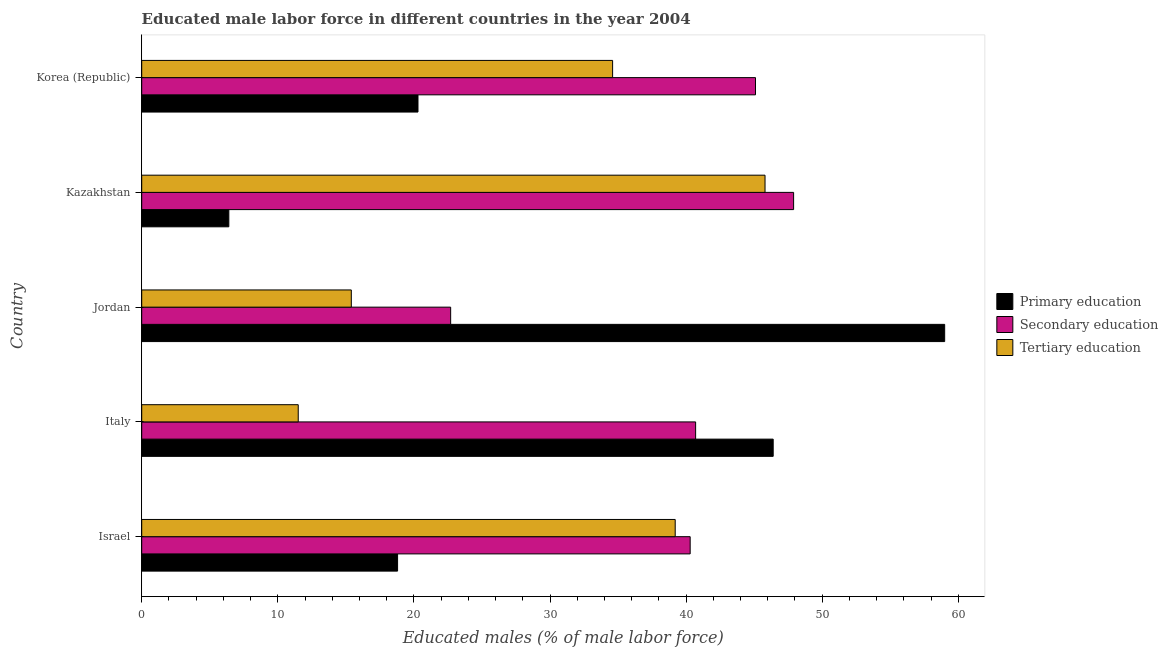How many different coloured bars are there?
Give a very brief answer. 3. Are the number of bars on each tick of the Y-axis equal?
Provide a succinct answer. Yes. How many bars are there on the 1st tick from the bottom?
Give a very brief answer. 3. What is the percentage of male labor force who received tertiary education in Israel?
Your response must be concise. 39.2. Across all countries, what is the maximum percentage of male labor force who received tertiary education?
Your response must be concise. 45.8. Across all countries, what is the minimum percentage of male labor force who received primary education?
Make the answer very short. 6.4. In which country was the percentage of male labor force who received primary education maximum?
Make the answer very short. Jordan. In which country was the percentage of male labor force who received tertiary education minimum?
Give a very brief answer. Italy. What is the total percentage of male labor force who received secondary education in the graph?
Your answer should be very brief. 196.7. What is the difference between the percentage of male labor force who received primary education in Italy and that in Jordan?
Provide a short and direct response. -12.6. What is the difference between the percentage of male labor force who received secondary education in Israel and the percentage of male labor force who received primary education in Jordan?
Provide a succinct answer. -18.7. What is the average percentage of male labor force who received tertiary education per country?
Your answer should be very brief. 29.3. In how many countries, is the percentage of male labor force who received primary education greater than 30 %?
Your answer should be very brief. 2. What is the ratio of the percentage of male labor force who received secondary education in Italy to that in Korea (Republic)?
Offer a very short reply. 0.9. What is the difference between the highest and the second highest percentage of male labor force who received primary education?
Your answer should be compact. 12.6. What is the difference between the highest and the lowest percentage of male labor force who received primary education?
Keep it short and to the point. 52.6. Is the sum of the percentage of male labor force who received secondary education in Israel and Korea (Republic) greater than the maximum percentage of male labor force who received primary education across all countries?
Your answer should be compact. Yes. What does the 2nd bar from the top in Kazakhstan represents?
Provide a succinct answer. Secondary education. Is it the case that in every country, the sum of the percentage of male labor force who received primary education and percentage of male labor force who received secondary education is greater than the percentage of male labor force who received tertiary education?
Offer a terse response. Yes. How many bars are there?
Provide a short and direct response. 15. Are all the bars in the graph horizontal?
Your answer should be very brief. Yes. What is the difference between two consecutive major ticks on the X-axis?
Ensure brevity in your answer.  10. Are the values on the major ticks of X-axis written in scientific E-notation?
Give a very brief answer. No. Does the graph contain any zero values?
Provide a short and direct response. No. How are the legend labels stacked?
Offer a very short reply. Vertical. What is the title of the graph?
Your answer should be compact. Educated male labor force in different countries in the year 2004. Does "Resident buildings and public services" appear as one of the legend labels in the graph?
Ensure brevity in your answer.  No. What is the label or title of the X-axis?
Keep it short and to the point. Educated males (% of male labor force). What is the label or title of the Y-axis?
Your response must be concise. Country. What is the Educated males (% of male labor force) of Primary education in Israel?
Offer a terse response. 18.8. What is the Educated males (% of male labor force) in Secondary education in Israel?
Provide a succinct answer. 40.3. What is the Educated males (% of male labor force) of Tertiary education in Israel?
Your answer should be compact. 39.2. What is the Educated males (% of male labor force) of Primary education in Italy?
Give a very brief answer. 46.4. What is the Educated males (% of male labor force) in Secondary education in Italy?
Ensure brevity in your answer.  40.7. What is the Educated males (% of male labor force) in Primary education in Jordan?
Provide a short and direct response. 59. What is the Educated males (% of male labor force) in Secondary education in Jordan?
Offer a terse response. 22.7. What is the Educated males (% of male labor force) of Tertiary education in Jordan?
Ensure brevity in your answer.  15.4. What is the Educated males (% of male labor force) in Primary education in Kazakhstan?
Provide a short and direct response. 6.4. What is the Educated males (% of male labor force) in Secondary education in Kazakhstan?
Make the answer very short. 47.9. What is the Educated males (% of male labor force) in Tertiary education in Kazakhstan?
Offer a very short reply. 45.8. What is the Educated males (% of male labor force) of Primary education in Korea (Republic)?
Your response must be concise. 20.3. What is the Educated males (% of male labor force) of Secondary education in Korea (Republic)?
Your answer should be very brief. 45.1. What is the Educated males (% of male labor force) in Tertiary education in Korea (Republic)?
Make the answer very short. 34.6. Across all countries, what is the maximum Educated males (% of male labor force) of Primary education?
Ensure brevity in your answer.  59. Across all countries, what is the maximum Educated males (% of male labor force) of Secondary education?
Provide a succinct answer. 47.9. Across all countries, what is the maximum Educated males (% of male labor force) of Tertiary education?
Provide a succinct answer. 45.8. Across all countries, what is the minimum Educated males (% of male labor force) of Primary education?
Provide a short and direct response. 6.4. Across all countries, what is the minimum Educated males (% of male labor force) of Secondary education?
Make the answer very short. 22.7. What is the total Educated males (% of male labor force) in Primary education in the graph?
Ensure brevity in your answer.  150.9. What is the total Educated males (% of male labor force) of Secondary education in the graph?
Provide a short and direct response. 196.7. What is the total Educated males (% of male labor force) in Tertiary education in the graph?
Offer a terse response. 146.5. What is the difference between the Educated males (% of male labor force) of Primary education in Israel and that in Italy?
Your answer should be very brief. -27.6. What is the difference between the Educated males (% of male labor force) in Secondary education in Israel and that in Italy?
Give a very brief answer. -0.4. What is the difference between the Educated males (% of male labor force) in Tertiary education in Israel and that in Italy?
Ensure brevity in your answer.  27.7. What is the difference between the Educated males (% of male labor force) of Primary education in Israel and that in Jordan?
Ensure brevity in your answer.  -40.2. What is the difference between the Educated males (% of male labor force) in Secondary education in Israel and that in Jordan?
Make the answer very short. 17.6. What is the difference between the Educated males (% of male labor force) of Tertiary education in Israel and that in Jordan?
Ensure brevity in your answer.  23.8. What is the difference between the Educated males (% of male labor force) of Tertiary education in Israel and that in Kazakhstan?
Your response must be concise. -6.6. What is the difference between the Educated males (% of male labor force) of Primary education in Israel and that in Korea (Republic)?
Offer a terse response. -1.5. What is the difference between the Educated males (% of male labor force) of Tertiary education in Israel and that in Korea (Republic)?
Offer a very short reply. 4.6. What is the difference between the Educated males (% of male labor force) in Secondary education in Italy and that in Jordan?
Make the answer very short. 18. What is the difference between the Educated males (% of male labor force) of Secondary education in Italy and that in Kazakhstan?
Provide a short and direct response. -7.2. What is the difference between the Educated males (% of male labor force) of Tertiary education in Italy and that in Kazakhstan?
Offer a very short reply. -34.3. What is the difference between the Educated males (% of male labor force) in Primary education in Italy and that in Korea (Republic)?
Your answer should be very brief. 26.1. What is the difference between the Educated males (% of male labor force) of Secondary education in Italy and that in Korea (Republic)?
Your answer should be compact. -4.4. What is the difference between the Educated males (% of male labor force) of Tertiary education in Italy and that in Korea (Republic)?
Give a very brief answer. -23.1. What is the difference between the Educated males (% of male labor force) of Primary education in Jordan and that in Kazakhstan?
Make the answer very short. 52.6. What is the difference between the Educated males (% of male labor force) of Secondary education in Jordan and that in Kazakhstan?
Make the answer very short. -25.2. What is the difference between the Educated males (% of male labor force) of Tertiary education in Jordan and that in Kazakhstan?
Your answer should be very brief. -30.4. What is the difference between the Educated males (% of male labor force) of Primary education in Jordan and that in Korea (Republic)?
Give a very brief answer. 38.7. What is the difference between the Educated males (% of male labor force) in Secondary education in Jordan and that in Korea (Republic)?
Make the answer very short. -22.4. What is the difference between the Educated males (% of male labor force) of Tertiary education in Jordan and that in Korea (Republic)?
Provide a succinct answer. -19.2. What is the difference between the Educated males (% of male labor force) in Primary education in Kazakhstan and that in Korea (Republic)?
Offer a terse response. -13.9. What is the difference between the Educated males (% of male labor force) in Tertiary education in Kazakhstan and that in Korea (Republic)?
Your response must be concise. 11.2. What is the difference between the Educated males (% of male labor force) in Primary education in Israel and the Educated males (% of male labor force) in Secondary education in Italy?
Provide a short and direct response. -21.9. What is the difference between the Educated males (% of male labor force) in Primary education in Israel and the Educated males (% of male labor force) in Tertiary education in Italy?
Provide a short and direct response. 7.3. What is the difference between the Educated males (% of male labor force) of Secondary education in Israel and the Educated males (% of male labor force) of Tertiary education in Italy?
Give a very brief answer. 28.8. What is the difference between the Educated males (% of male labor force) of Secondary education in Israel and the Educated males (% of male labor force) of Tertiary education in Jordan?
Provide a short and direct response. 24.9. What is the difference between the Educated males (% of male labor force) in Primary education in Israel and the Educated males (% of male labor force) in Secondary education in Kazakhstan?
Provide a succinct answer. -29.1. What is the difference between the Educated males (% of male labor force) of Primary education in Israel and the Educated males (% of male labor force) of Tertiary education in Kazakhstan?
Provide a succinct answer. -27. What is the difference between the Educated males (% of male labor force) in Primary education in Israel and the Educated males (% of male labor force) in Secondary education in Korea (Republic)?
Make the answer very short. -26.3. What is the difference between the Educated males (% of male labor force) of Primary education in Israel and the Educated males (% of male labor force) of Tertiary education in Korea (Republic)?
Offer a terse response. -15.8. What is the difference between the Educated males (% of male labor force) of Primary education in Italy and the Educated males (% of male labor force) of Secondary education in Jordan?
Make the answer very short. 23.7. What is the difference between the Educated males (% of male labor force) of Primary education in Italy and the Educated males (% of male labor force) of Tertiary education in Jordan?
Make the answer very short. 31. What is the difference between the Educated males (% of male labor force) in Secondary education in Italy and the Educated males (% of male labor force) in Tertiary education in Jordan?
Offer a terse response. 25.3. What is the difference between the Educated males (% of male labor force) in Primary education in Italy and the Educated males (% of male labor force) in Tertiary education in Kazakhstan?
Provide a succinct answer. 0.6. What is the difference between the Educated males (% of male labor force) of Secondary education in Italy and the Educated males (% of male labor force) of Tertiary education in Kazakhstan?
Offer a terse response. -5.1. What is the difference between the Educated males (% of male labor force) in Primary education in Italy and the Educated males (% of male labor force) in Secondary education in Korea (Republic)?
Your response must be concise. 1.3. What is the difference between the Educated males (% of male labor force) in Primary education in Italy and the Educated males (% of male labor force) in Tertiary education in Korea (Republic)?
Provide a succinct answer. 11.8. What is the difference between the Educated males (% of male labor force) in Primary education in Jordan and the Educated males (% of male labor force) in Secondary education in Kazakhstan?
Provide a short and direct response. 11.1. What is the difference between the Educated males (% of male labor force) of Secondary education in Jordan and the Educated males (% of male labor force) of Tertiary education in Kazakhstan?
Make the answer very short. -23.1. What is the difference between the Educated males (% of male labor force) in Primary education in Jordan and the Educated males (% of male labor force) in Secondary education in Korea (Republic)?
Your response must be concise. 13.9. What is the difference between the Educated males (% of male labor force) in Primary education in Jordan and the Educated males (% of male labor force) in Tertiary education in Korea (Republic)?
Ensure brevity in your answer.  24.4. What is the difference between the Educated males (% of male labor force) of Secondary education in Jordan and the Educated males (% of male labor force) of Tertiary education in Korea (Republic)?
Make the answer very short. -11.9. What is the difference between the Educated males (% of male labor force) in Primary education in Kazakhstan and the Educated males (% of male labor force) in Secondary education in Korea (Republic)?
Offer a terse response. -38.7. What is the difference between the Educated males (% of male labor force) of Primary education in Kazakhstan and the Educated males (% of male labor force) of Tertiary education in Korea (Republic)?
Offer a terse response. -28.2. What is the difference between the Educated males (% of male labor force) of Secondary education in Kazakhstan and the Educated males (% of male labor force) of Tertiary education in Korea (Republic)?
Provide a succinct answer. 13.3. What is the average Educated males (% of male labor force) of Primary education per country?
Your answer should be very brief. 30.18. What is the average Educated males (% of male labor force) in Secondary education per country?
Your answer should be very brief. 39.34. What is the average Educated males (% of male labor force) of Tertiary education per country?
Give a very brief answer. 29.3. What is the difference between the Educated males (% of male labor force) in Primary education and Educated males (% of male labor force) in Secondary education in Israel?
Offer a very short reply. -21.5. What is the difference between the Educated males (% of male labor force) of Primary education and Educated males (% of male labor force) of Tertiary education in Israel?
Provide a short and direct response. -20.4. What is the difference between the Educated males (% of male labor force) of Secondary education and Educated males (% of male labor force) of Tertiary education in Israel?
Provide a short and direct response. 1.1. What is the difference between the Educated males (% of male labor force) in Primary education and Educated males (% of male labor force) in Secondary education in Italy?
Make the answer very short. 5.7. What is the difference between the Educated males (% of male labor force) in Primary education and Educated males (% of male labor force) in Tertiary education in Italy?
Your response must be concise. 34.9. What is the difference between the Educated males (% of male labor force) of Secondary education and Educated males (% of male labor force) of Tertiary education in Italy?
Your answer should be compact. 29.2. What is the difference between the Educated males (% of male labor force) of Primary education and Educated males (% of male labor force) of Secondary education in Jordan?
Provide a succinct answer. 36.3. What is the difference between the Educated males (% of male labor force) in Primary education and Educated males (% of male labor force) in Tertiary education in Jordan?
Make the answer very short. 43.6. What is the difference between the Educated males (% of male labor force) of Primary education and Educated males (% of male labor force) of Secondary education in Kazakhstan?
Ensure brevity in your answer.  -41.5. What is the difference between the Educated males (% of male labor force) in Primary education and Educated males (% of male labor force) in Tertiary education in Kazakhstan?
Provide a short and direct response. -39.4. What is the difference between the Educated males (% of male labor force) in Primary education and Educated males (% of male labor force) in Secondary education in Korea (Republic)?
Your answer should be very brief. -24.8. What is the difference between the Educated males (% of male labor force) in Primary education and Educated males (% of male labor force) in Tertiary education in Korea (Republic)?
Your response must be concise. -14.3. What is the ratio of the Educated males (% of male labor force) of Primary education in Israel to that in Italy?
Make the answer very short. 0.41. What is the ratio of the Educated males (% of male labor force) of Secondary education in Israel to that in Italy?
Make the answer very short. 0.99. What is the ratio of the Educated males (% of male labor force) of Tertiary education in Israel to that in Italy?
Offer a very short reply. 3.41. What is the ratio of the Educated males (% of male labor force) of Primary education in Israel to that in Jordan?
Offer a terse response. 0.32. What is the ratio of the Educated males (% of male labor force) in Secondary education in Israel to that in Jordan?
Keep it short and to the point. 1.78. What is the ratio of the Educated males (% of male labor force) in Tertiary education in Israel to that in Jordan?
Your answer should be very brief. 2.55. What is the ratio of the Educated males (% of male labor force) in Primary education in Israel to that in Kazakhstan?
Provide a succinct answer. 2.94. What is the ratio of the Educated males (% of male labor force) in Secondary education in Israel to that in Kazakhstan?
Give a very brief answer. 0.84. What is the ratio of the Educated males (% of male labor force) in Tertiary education in Israel to that in Kazakhstan?
Give a very brief answer. 0.86. What is the ratio of the Educated males (% of male labor force) of Primary education in Israel to that in Korea (Republic)?
Provide a short and direct response. 0.93. What is the ratio of the Educated males (% of male labor force) in Secondary education in Israel to that in Korea (Republic)?
Offer a terse response. 0.89. What is the ratio of the Educated males (% of male labor force) of Tertiary education in Israel to that in Korea (Republic)?
Ensure brevity in your answer.  1.13. What is the ratio of the Educated males (% of male labor force) in Primary education in Italy to that in Jordan?
Your response must be concise. 0.79. What is the ratio of the Educated males (% of male labor force) of Secondary education in Italy to that in Jordan?
Offer a terse response. 1.79. What is the ratio of the Educated males (% of male labor force) in Tertiary education in Italy to that in Jordan?
Your answer should be very brief. 0.75. What is the ratio of the Educated males (% of male labor force) in Primary education in Italy to that in Kazakhstan?
Give a very brief answer. 7.25. What is the ratio of the Educated males (% of male labor force) in Secondary education in Italy to that in Kazakhstan?
Your answer should be compact. 0.85. What is the ratio of the Educated males (% of male labor force) in Tertiary education in Italy to that in Kazakhstan?
Provide a succinct answer. 0.25. What is the ratio of the Educated males (% of male labor force) of Primary education in Italy to that in Korea (Republic)?
Offer a terse response. 2.29. What is the ratio of the Educated males (% of male labor force) of Secondary education in Italy to that in Korea (Republic)?
Give a very brief answer. 0.9. What is the ratio of the Educated males (% of male labor force) of Tertiary education in Italy to that in Korea (Republic)?
Provide a short and direct response. 0.33. What is the ratio of the Educated males (% of male labor force) of Primary education in Jordan to that in Kazakhstan?
Provide a succinct answer. 9.22. What is the ratio of the Educated males (% of male labor force) of Secondary education in Jordan to that in Kazakhstan?
Make the answer very short. 0.47. What is the ratio of the Educated males (% of male labor force) of Tertiary education in Jordan to that in Kazakhstan?
Ensure brevity in your answer.  0.34. What is the ratio of the Educated males (% of male labor force) of Primary education in Jordan to that in Korea (Republic)?
Ensure brevity in your answer.  2.91. What is the ratio of the Educated males (% of male labor force) of Secondary education in Jordan to that in Korea (Republic)?
Make the answer very short. 0.5. What is the ratio of the Educated males (% of male labor force) of Tertiary education in Jordan to that in Korea (Republic)?
Your answer should be very brief. 0.45. What is the ratio of the Educated males (% of male labor force) of Primary education in Kazakhstan to that in Korea (Republic)?
Your answer should be very brief. 0.32. What is the ratio of the Educated males (% of male labor force) in Secondary education in Kazakhstan to that in Korea (Republic)?
Ensure brevity in your answer.  1.06. What is the ratio of the Educated males (% of male labor force) of Tertiary education in Kazakhstan to that in Korea (Republic)?
Ensure brevity in your answer.  1.32. What is the difference between the highest and the second highest Educated males (% of male labor force) of Primary education?
Provide a short and direct response. 12.6. What is the difference between the highest and the lowest Educated males (% of male labor force) in Primary education?
Your response must be concise. 52.6. What is the difference between the highest and the lowest Educated males (% of male labor force) of Secondary education?
Make the answer very short. 25.2. What is the difference between the highest and the lowest Educated males (% of male labor force) of Tertiary education?
Provide a short and direct response. 34.3. 